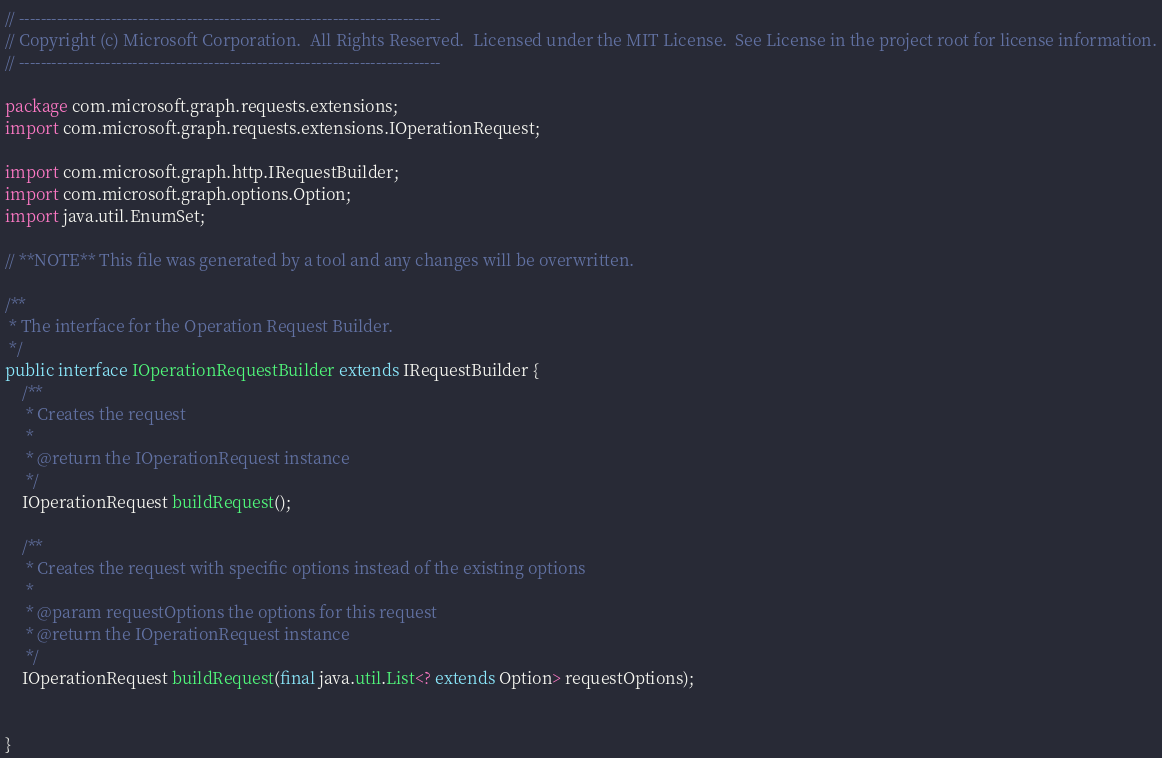<code> <loc_0><loc_0><loc_500><loc_500><_Java_>// ------------------------------------------------------------------------------
// Copyright (c) Microsoft Corporation.  All Rights Reserved.  Licensed under the MIT License.  See License in the project root for license information.
// ------------------------------------------------------------------------------

package com.microsoft.graph.requests.extensions;
import com.microsoft.graph.requests.extensions.IOperationRequest;

import com.microsoft.graph.http.IRequestBuilder;
import com.microsoft.graph.options.Option;
import java.util.EnumSet;

// **NOTE** This file was generated by a tool and any changes will be overwritten.

/**
 * The interface for the Operation Request Builder.
 */
public interface IOperationRequestBuilder extends IRequestBuilder {
    /**
     * Creates the request
     *
     * @return the IOperationRequest instance
     */
    IOperationRequest buildRequest();

    /**
     * Creates the request with specific options instead of the existing options
     *
     * @param requestOptions the options for this request
     * @return the IOperationRequest instance
     */
    IOperationRequest buildRequest(final java.util.List<? extends Option> requestOptions);


}
</code> 